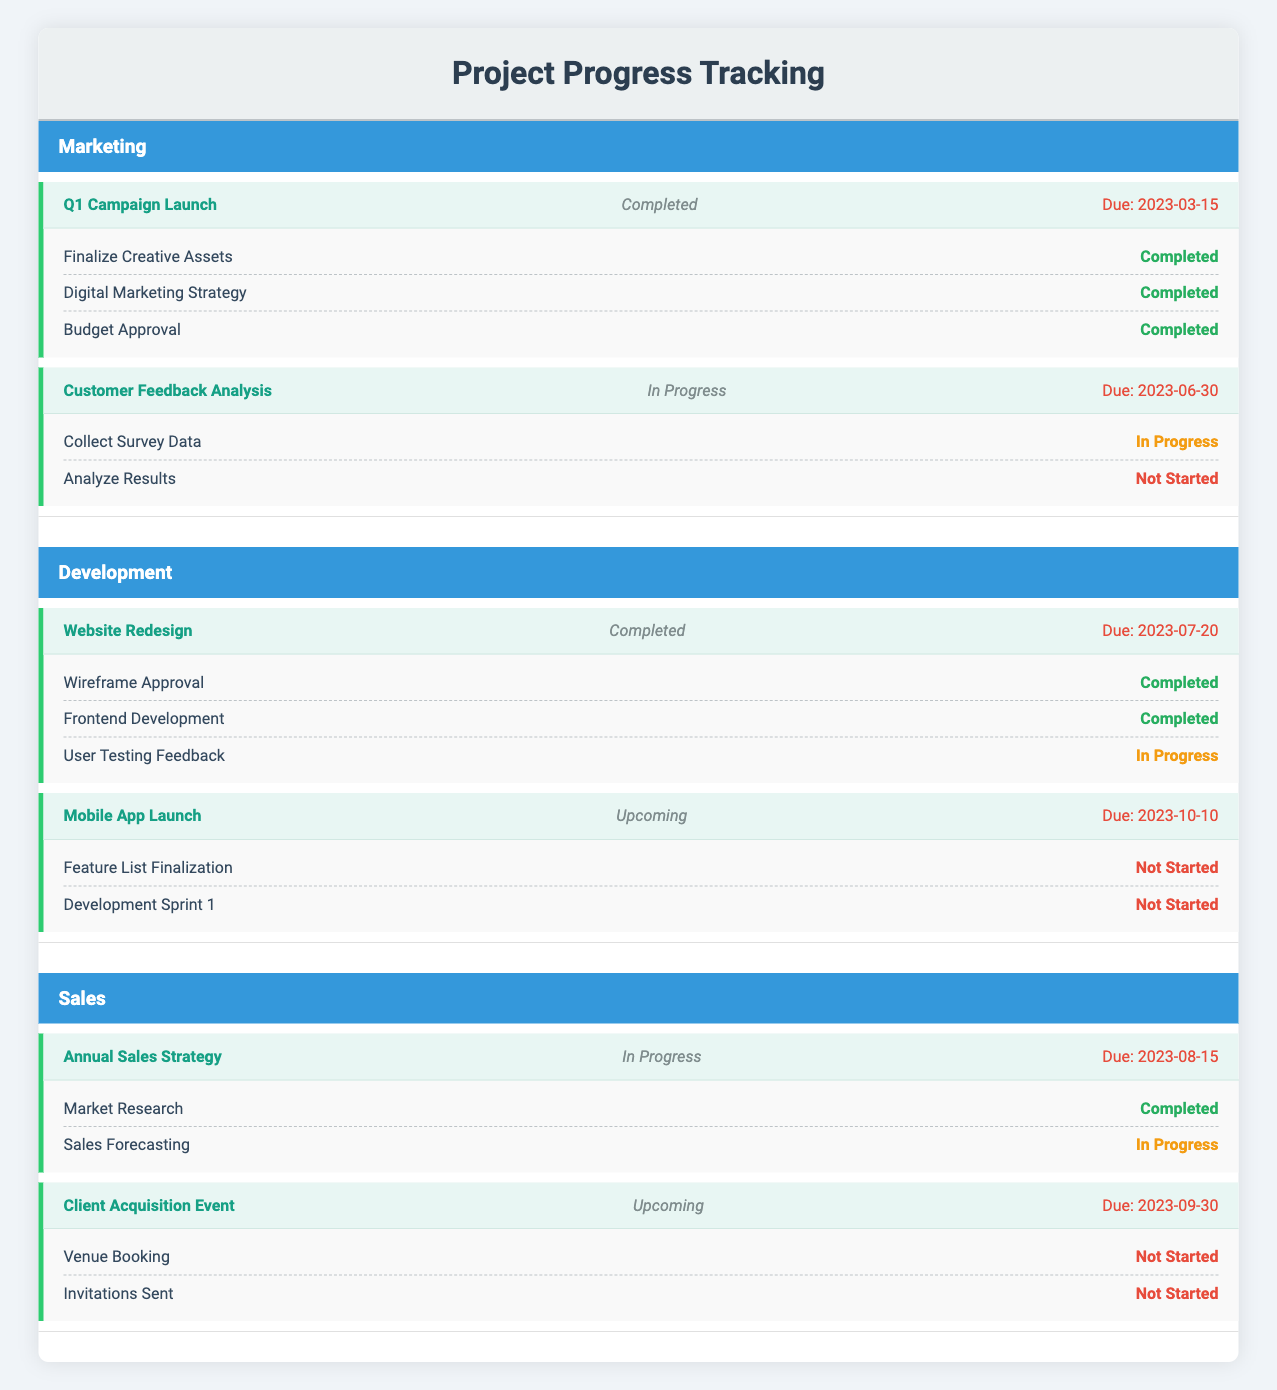What is the progress of the "Customer Feedback Analysis" milestone? The progress of the "Customer Feedback Analysis" milestone can be found in the milestone section under the Marketing team. It is noted as "In Progress."
Answer: In Progress How many subtasks are there under the "Website Redesign" milestone? Under the "Website Redesign" milestone in the Development team, there are three subtasks listed: "Wireframe Approval," "Frontend Development," and "User Testing Feedback."
Answer: Three Is the "Mobile App Launch" milestone completed? Looking at the status of the "Mobile App Launch" milestone under the Development team, it is marked as "Upcoming," indicating that it has not yet been completed.
Answer: No What is the due date for the "Client Acquisition Event"? The "Client Acquisition Event" milestone from the Sales team has a due date listed as "2023-09-30."
Answer: 2023-09-30 Which team has the milestone with the farthest due date? Analyzing the due dates across all teams' milestones: "Q1 Campaign Launch" (2023-03-15), "Customer Feedback Analysis" (2023-06-30), "Website Redesign" (2023-07-20), "Annual Sales Strategy" (2023-08-15), and "Mobile App Launch" (2023-10-10). The milestone with the farthest due date is "Mobile App Launch" on 2023-10-10.
Answer: Development How many subtasks are marked as "Not Started" across all teams? By reviewing each milestone: "Analyze Results" (Marketing) has 1 not started, "Feature List Finalization" and "Development Sprint 1" (Development) both have 2, and "Venue Booking" and "Invitations Sent" (Sales) have 2 as well. Adding them gives: 1 + 2 + 2 = 5 not started.
Answer: Five What percentage of subtasks are completed in the "Annual Sales Strategy"? For the "Annual Sales Strategy" milestone in the Sales team, there are 2 subtasks total. "Market Research" is completed (1) and "Sales Forecasting" is in progress (0). Only 1 out of 2 subtasks is completed, which calculates to (1/2) * 100 = 50%.
Answer: 50% Are all subtasks under the "Q1 Campaign Launch" milestone completed? Reviewing the subtasks shows that all three subtasks under this milestone: "Finalize Creative Assets," "Digital Marketing Strategy," and "Budget Approval" are marked as completed, indicating that yes, they are all completed.
Answer: Yes Which team's milestone has the most subtasks? The "Website Redesign" milestone from the Development team has three subtasks ("Wireframe Approval," "Frontend Development," "User Testing Feedback"), while other teams have fewer. Therefore, the Development team has the milestone with the most subtasks.
Answer: Development 